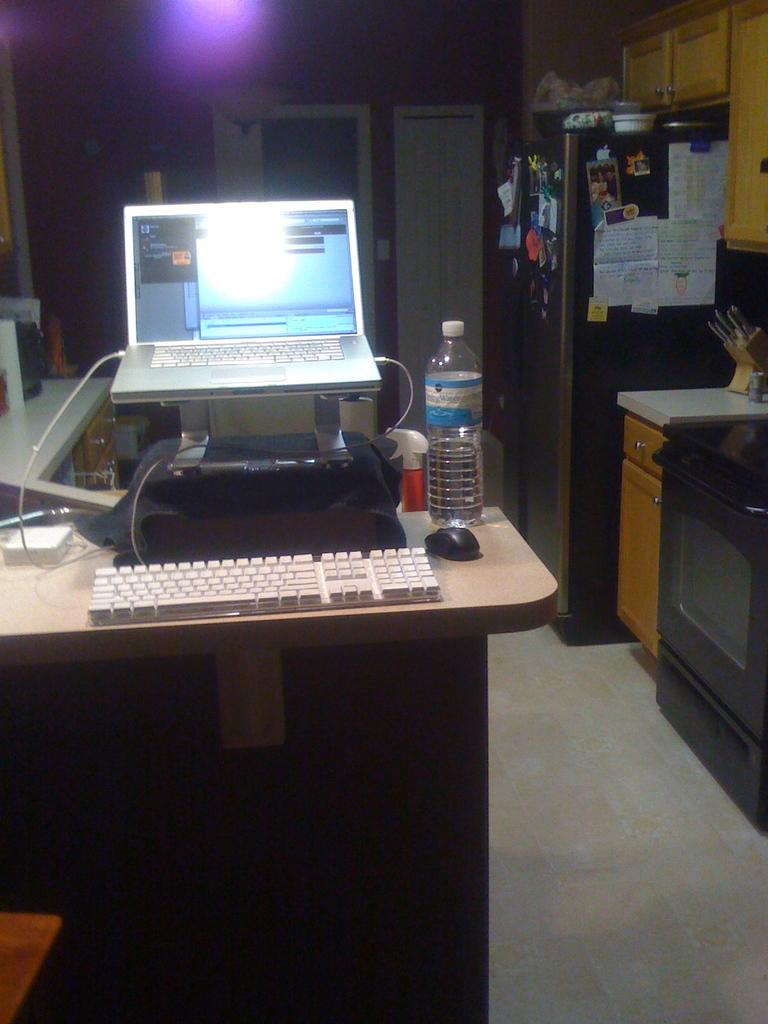What type of furniture is present in the image? There is an almara, a table, and a wall in the image. What is on the table in the image? There is a screen, a keyboard, a mouse, and a bottle on the table. Can you describe the wall in the image? The wall is a part of the background and does not have any specific features mentioned. What type of chalk is being used to write on the wall in the image? There is no chalk or writing on the wall in the image. Can you tell me how many keys are on the keyboard in the image? The number of keys on the keyboard is not mentioned in the image. 